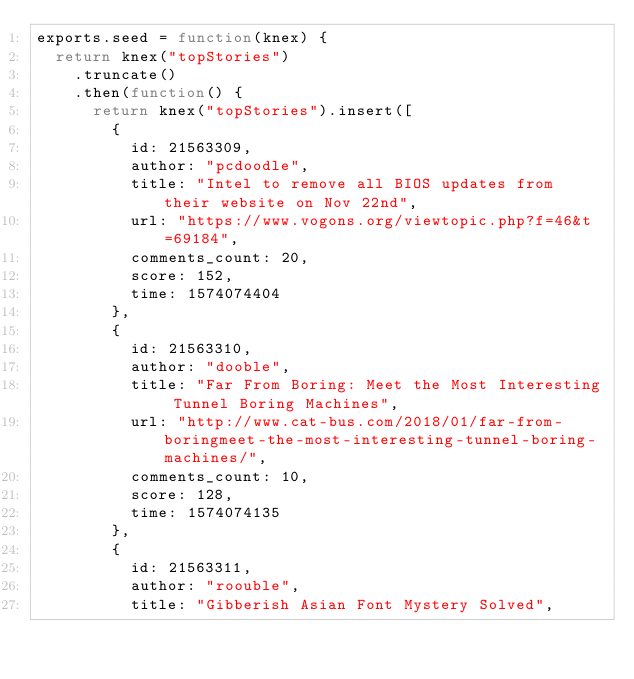Convert code to text. <code><loc_0><loc_0><loc_500><loc_500><_JavaScript_>exports.seed = function(knex) {
  return knex("topStories")
    .truncate()
    .then(function() {
      return knex("topStories").insert([
        {
          id: 21563309,
          author: "pcdoodle",
          title: "Intel to remove all BIOS updates from their website on Nov 22nd",
          url: "https://www.vogons.org/viewtopic.php?f=46&t=69184",
          comments_count: 20,
          score: 152,
          time: 1574074404
        },
        {
          id: 21563310,
          author: "dooble",
          title: "Far From Boring: Meet the Most Interesting Tunnel Boring Machines",
          url: "http://www.cat-bus.com/2018/01/far-from-boringmeet-the-most-interesting-tunnel-boring-machines/",
          comments_count: 10,
          score: 128,
          time: 1574074135
        },
        {
          id: 21563311,
          author: "roouble",
          title: "Gibberish Asian Font Mystery Solved",</code> 